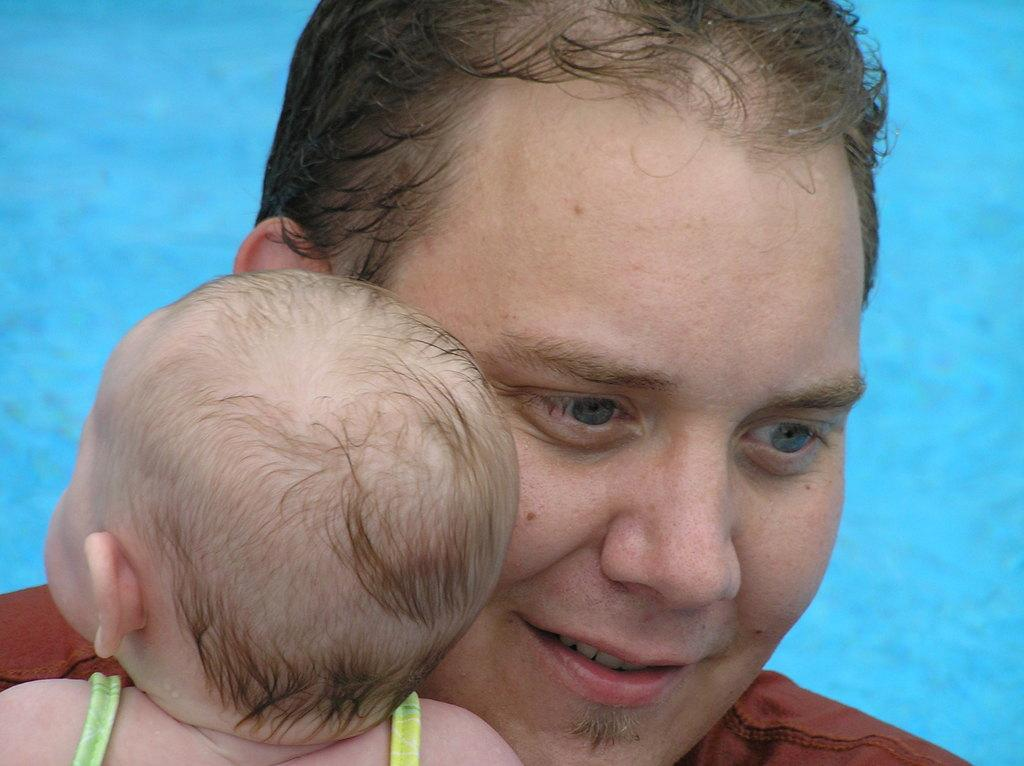What is the main subject of the image? The main subject of the image is a man. Can you describe the man's expression in the image? The man is smiling in the image. What other person or object is present in the image? There is a baby in the image. What can be seen in the background of the image? Water is visible in the background of the image. What type of insect is crawling on the man's shoulder in the image? There is no insect present on the man's shoulder in the image. What adjustment does the man need to make to his partner in the image? There is no partner present in the image, and therefore no adjustment is necessary. 